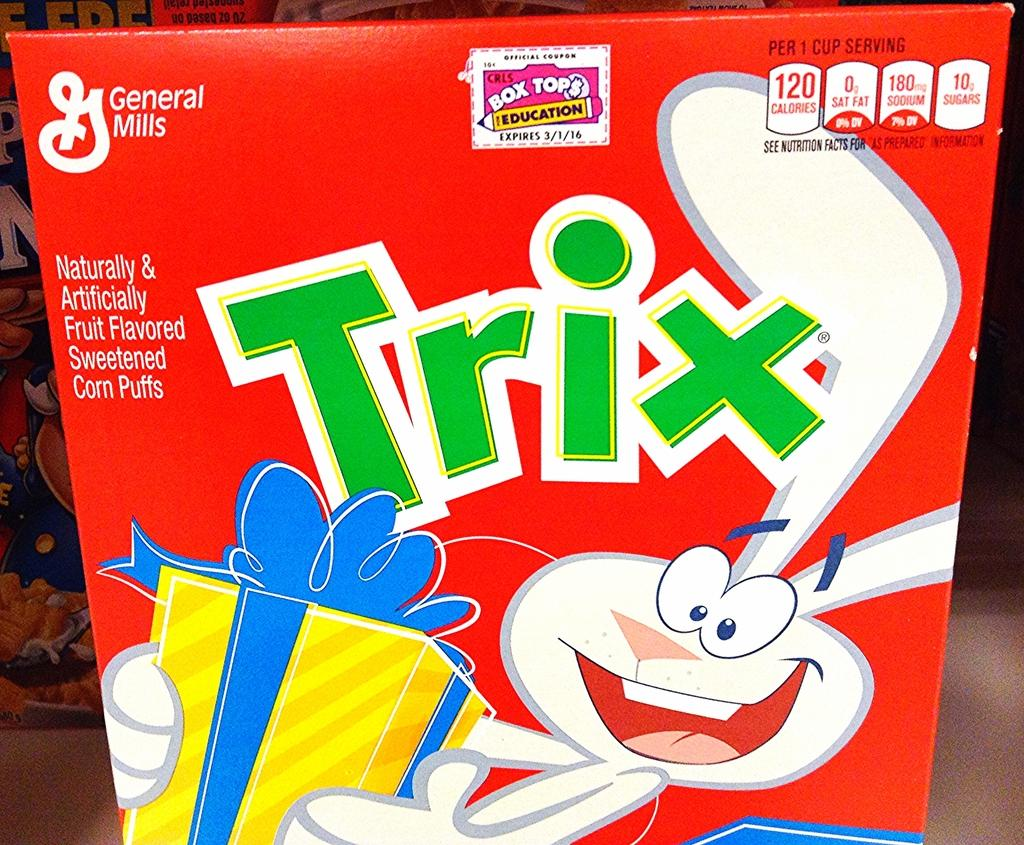What object is present in the image that is made of cardboard? There is a cardboard box in the image. What is depicted on the cardboard box? The cardboard box has a picture of a cartoon on it. What else can be found on the cardboard box besides the cartoon image? There is text on the cardboard box. How many children are playing with the grandmother near the cardboard box in the image? There are no children or grandmother present in the image; it only features a cardboard box with a cartoon image and text. 